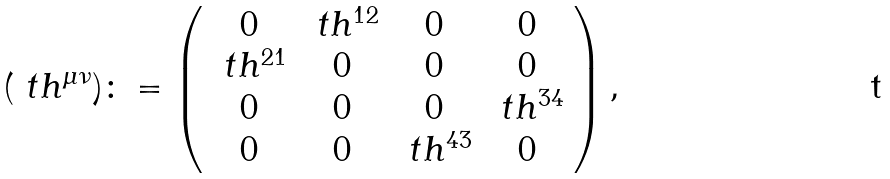<formula> <loc_0><loc_0><loc_500><loc_500>( \ t h ^ { \mu \nu } ) \colon = \left ( \begin{array} { c c c c } 0 & \ t h ^ { 1 2 } & 0 & 0 \\ \ t h ^ { 2 1 } & 0 & 0 & 0 \\ 0 & 0 & 0 & \ t h ^ { 3 4 } \\ 0 & 0 & \ t h ^ { 4 3 } & 0 \end{array} \right ) ,</formula> 